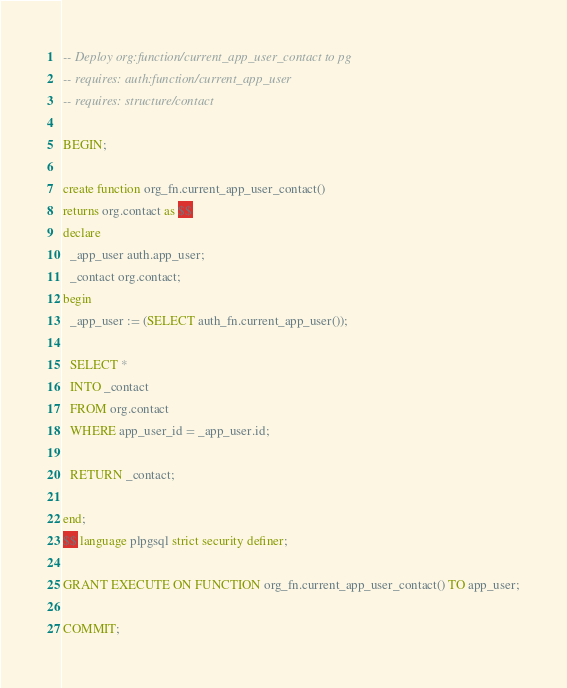<code> <loc_0><loc_0><loc_500><loc_500><_SQL_>-- Deploy org:function/current_app_user_contact to pg
-- requires: auth:function/current_app_user
-- requires: structure/contact

BEGIN;

create function org_fn.current_app_user_contact()
returns org.contact as $$
declare
  _app_user auth.app_user;
  _contact org.contact;
begin
  _app_user := (SELECT auth_fn.current_app_user());

  SELECT *
  INTO _contact
  FROM org.contact
  WHERE app_user_id = _app_user.id;

  RETURN _contact;

end;
$$ language plpgsql strict security definer;

GRANT EXECUTE ON FUNCTION org_fn.current_app_user_contact() TO app_user;

COMMIT;</code> 